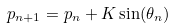Convert formula to latex. <formula><loc_0><loc_0><loc_500><loc_500>p _ { n + 1 } = p _ { n } + K \sin ( \theta _ { n } )</formula> 